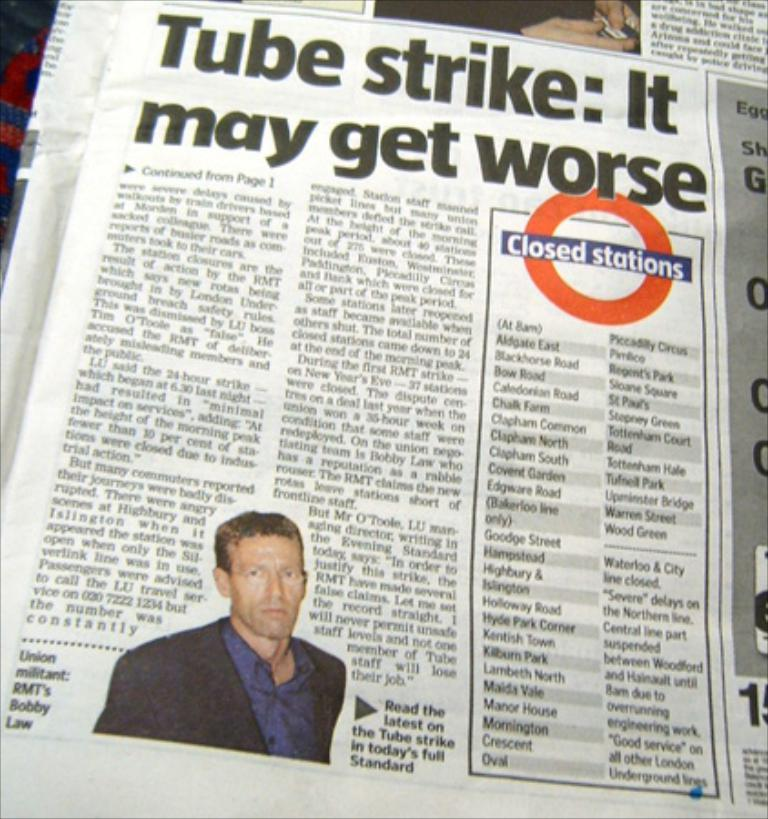Provide a one-sentence caption for the provided image. a paper that has the words tube strike in it. 